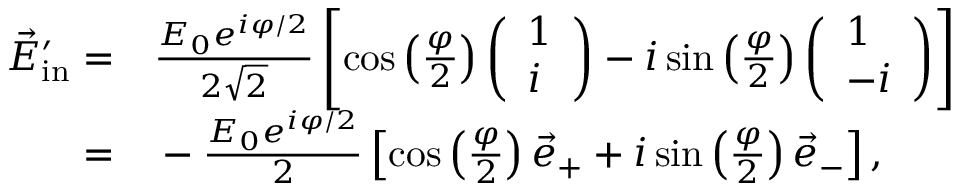Convert formula to latex. <formula><loc_0><loc_0><loc_500><loc_500>\begin{array} { r l } { \vec { E } _ { i n } ^ { \prime } = } & \frac { E _ { 0 } e ^ { i \varphi / 2 } } { 2 \sqrt { 2 } } \left [ \cos \left ( \frac { \varphi } { 2 } \right ) \left ( \begin{array} { l } { 1 } \\ { i } \end{array} \right ) - i \sin \left ( \frac { \varphi } { 2 } \right ) \left ( \begin{array} { l } { 1 } \\ { - i } \end{array} \right ) \right ] } \\ { = } & - \frac { E _ { 0 } e ^ { i \varphi / 2 } } { 2 } \left [ \cos \left ( \frac { \varphi } { 2 } \right ) \vec { e } _ { + } + i \sin \left ( \frac { \varphi } { 2 } \right ) \vec { e } _ { - } \right ] , } \end{array}</formula> 